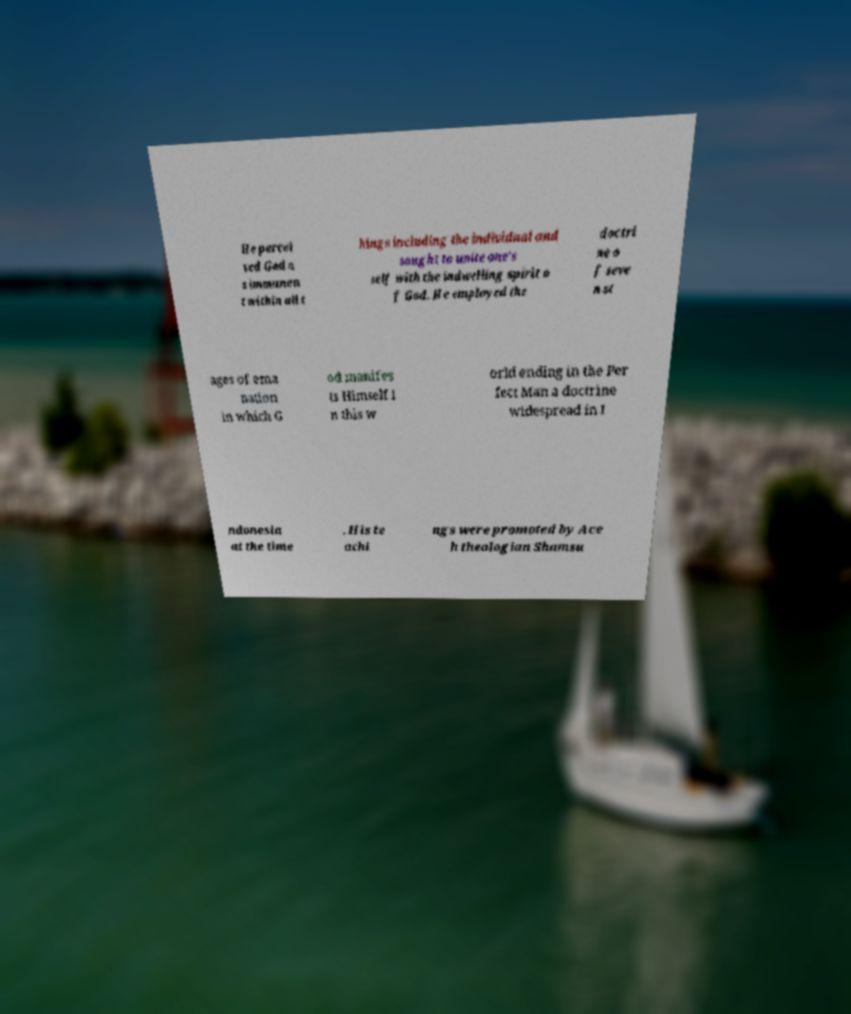Could you assist in decoding the text presented in this image and type it out clearly? He percei ved God a s immanen t within all t hings including the individual and sought to unite one's self with the indwelling spirit o f God. He employed the doctri ne o f seve n st ages of ema nation in which G od manifes ts Himself i n this w orld ending in the Per fect Man a doctrine widespread in I ndonesia at the time . His te achi ngs were promoted by Ace h theologian Shamsu 